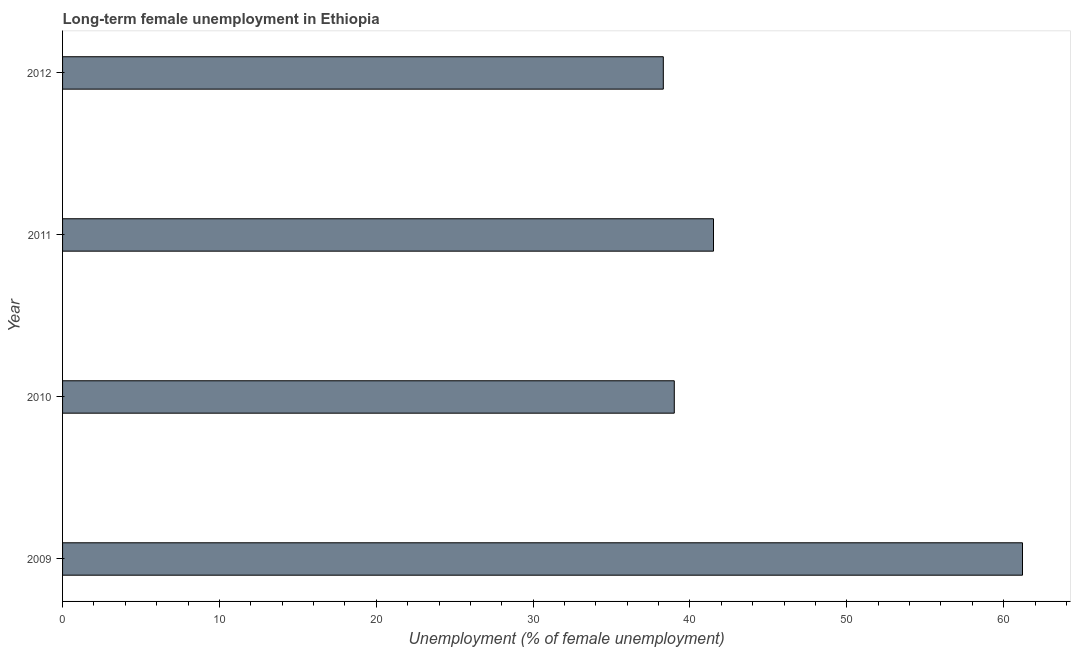What is the title of the graph?
Offer a very short reply. Long-term female unemployment in Ethiopia. What is the label or title of the X-axis?
Keep it short and to the point. Unemployment (% of female unemployment). What is the label or title of the Y-axis?
Provide a succinct answer. Year. What is the long-term female unemployment in 2009?
Ensure brevity in your answer.  61.2. Across all years, what is the maximum long-term female unemployment?
Your answer should be very brief. 61.2. Across all years, what is the minimum long-term female unemployment?
Provide a succinct answer. 38.3. In which year was the long-term female unemployment maximum?
Keep it short and to the point. 2009. In which year was the long-term female unemployment minimum?
Give a very brief answer. 2012. What is the sum of the long-term female unemployment?
Give a very brief answer. 180. What is the median long-term female unemployment?
Your answer should be compact. 40.25. What is the ratio of the long-term female unemployment in 2009 to that in 2012?
Give a very brief answer. 1.6. Is the long-term female unemployment in 2010 less than that in 2012?
Offer a very short reply. No. Is the difference between the long-term female unemployment in 2010 and 2011 greater than the difference between any two years?
Offer a very short reply. No. What is the difference between the highest and the lowest long-term female unemployment?
Your answer should be very brief. 22.9. In how many years, is the long-term female unemployment greater than the average long-term female unemployment taken over all years?
Make the answer very short. 1. Are all the bars in the graph horizontal?
Make the answer very short. Yes. How many years are there in the graph?
Offer a terse response. 4. Are the values on the major ticks of X-axis written in scientific E-notation?
Offer a terse response. No. What is the Unemployment (% of female unemployment) in 2009?
Offer a very short reply. 61.2. What is the Unemployment (% of female unemployment) in 2010?
Make the answer very short. 39. What is the Unemployment (% of female unemployment) of 2011?
Your answer should be very brief. 41.5. What is the Unemployment (% of female unemployment) of 2012?
Offer a terse response. 38.3. What is the difference between the Unemployment (% of female unemployment) in 2009 and 2010?
Your answer should be very brief. 22.2. What is the difference between the Unemployment (% of female unemployment) in 2009 and 2012?
Ensure brevity in your answer.  22.9. What is the difference between the Unemployment (% of female unemployment) in 2011 and 2012?
Give a very brief answer. 3.2. What is the ratio of the Unemployment (% of female unemployment) in 2009 to that in 2010?
Your answer should be very brief. 1.57. What is the ratio of the Unemployment (% of female unemployment) in 2009 to that in 2011?
Provide a short and direct response. 1.48. What is the ratio of the Unemployment (% of female unemployment) in 2009 to that in 2012?
Give a very brief answer. 1.6. What is the ratio of the Unemployment (% of female unemployment) in 2011 to that in 2012?
Provide a short and direct response. 1.08. 